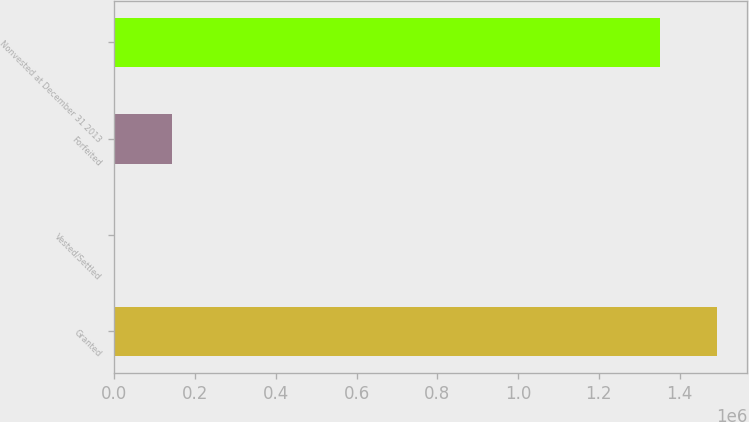<chart> <loc_0><loc_0><loc_500><loc_500><bar_chart><fcel>Granted<fcel>Vested/Settled<fcel>Forfeited<fcel>Nonvested at December 31 2013<nl><fcel>1.49304e+06<fcel>1844<fcel>143314<fcel>1.35157e+06<nl></chart> 